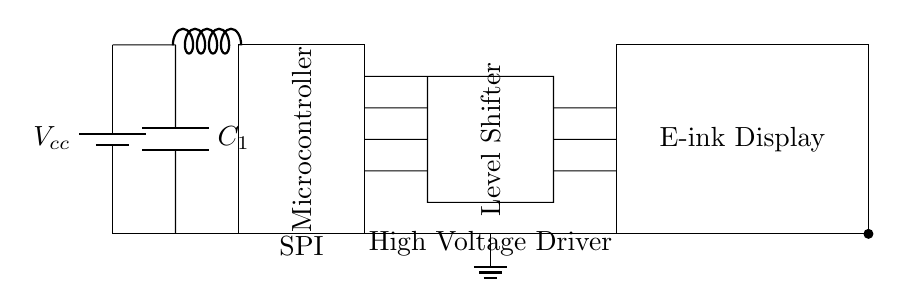What is the main power supply voltage in this circuit? The power supply, indicated as Vcc in the circuit, represents the main voltage that powers the entire circuit. The exact value is not specified in the diagram, but it typically will be a low voltage suitable for e-ink applications, such as 3.3V or 5V.
Answer: Vcc What does the microcontroller do in this circuit? The microcontroller is responsible for processing data and controlling the e-ink display. It interfaces with the display via SPI communication, sending commands and data signals to refresh the screen and display content.
Answer: Control signals What is the purpose of the voltage regulator in this circuit? The voltage regulator ensures that the circuit receives a stable voltage from the power supply. It steps down or regulates the input voltage to a level that is usable by the microcontroller and e-ink display, preventing damage from over-voltage.
Answer: Voltage regulation How many connections does the level shifter have in the circuit? The level shifter has three connections going to the microcontroller and three connections going to the e-ink display. This totals to six connections, which facilitate communication between devices operating at different voltage levels.
Answer: Six Explain the function of the capacitor labeled C1. Capacitor C1 is typically used for filtering and stabilizing the voltage supplied to the microcontroller. It helps smooth out fluctuations in voltage, providing a stable supply by absorbing spikes and dips, which is crucial for the reliable operation of digital circuits.
Answer: Filtering and stabilization What kind of communication method is used between the microcontroller and e-ink display? The communication method used is SPI, which stands for Serial Peripheral Interface. This is indicated in the circuit with the label SPI and is a standard protocol for connecting microcontrollers to peripherals like displays.
Answer: SPI What is the application of this circuit diagram? This diagram represents a low-power e-ink display driver circuit, commonly used in electronic reading devices such as e-readers. The low power aspect is critical for extending battery life in portable devices while utilizing e-ink technology for improved visibility and reduced power consumption during static image display.
Answer: Electronic reading devices 